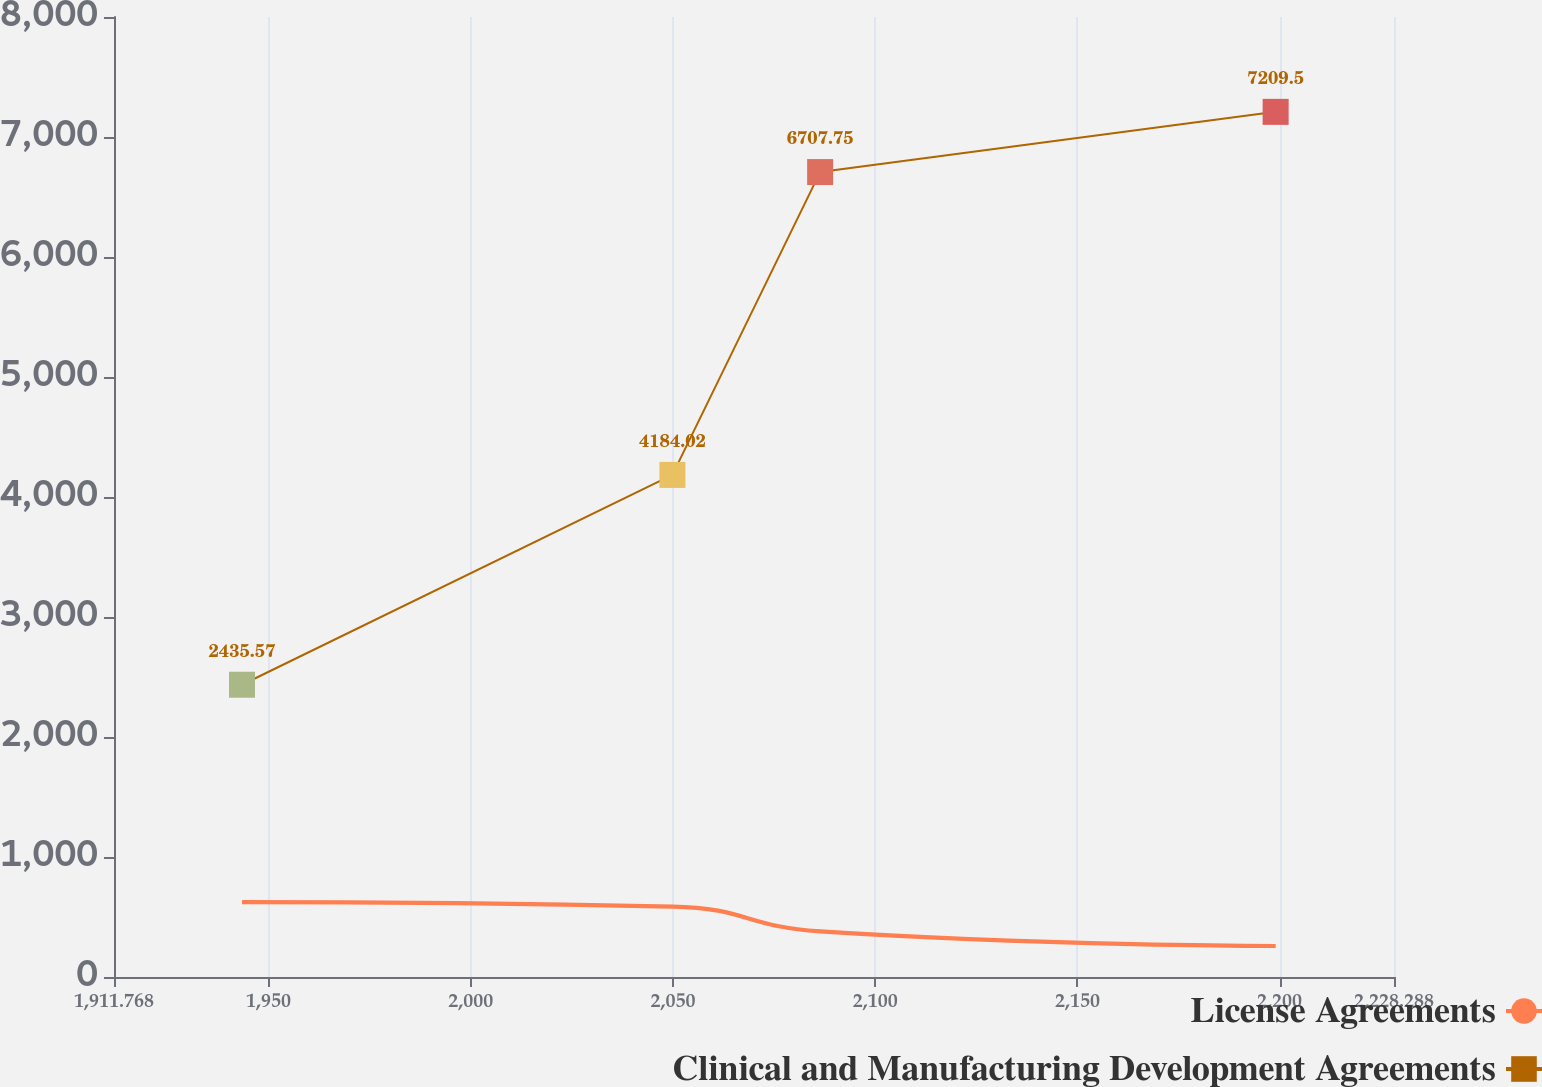<chart> <loc_0><loc_0><loc_500><loc_500><line_chart><ecel><fcel>License Agreements<fcel>Clinical and Manufacturing Development Agreements<nl><fcel>1943.42<fcel>623.2<fcel>2435.57<nl><fcel>2049.85<fcel>587.18<fcel>4184.02<nl><fcel>2086.38<fcel>379.77<fcel>6707.75<nl><fcel>2199.02<fcel>258.37<fcel>7209.5<nl><fcel>2259.94<fcel>343.75<fcel>7711.25<nl></chart> 